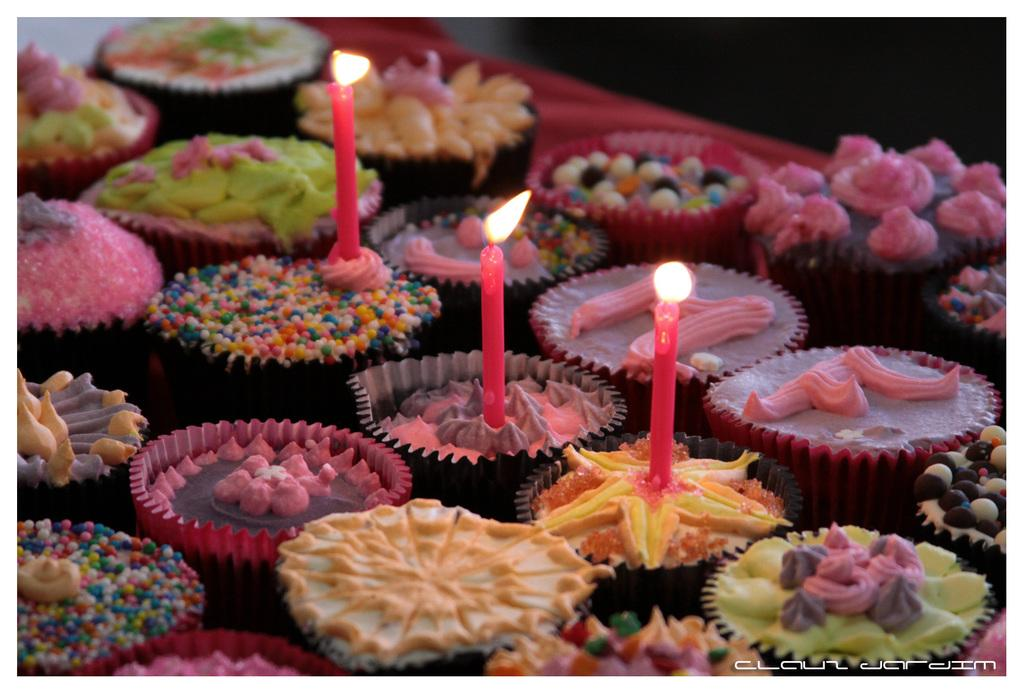What type of food is present on the table in the image? There are cupcakes on the table in the image. Can you describe the variety of cupcakes? There are different types of cupcakes visible in the image. What is placed on top of some of the cupcakes? There are three candles on three cupcakes in the image. What color is the tablecloth covering the table? The table is covered with a red cloth in the image. How do the giants interact with the cupcakes in the image? There are no giants present in the image, so it is not possible to answer that question. 